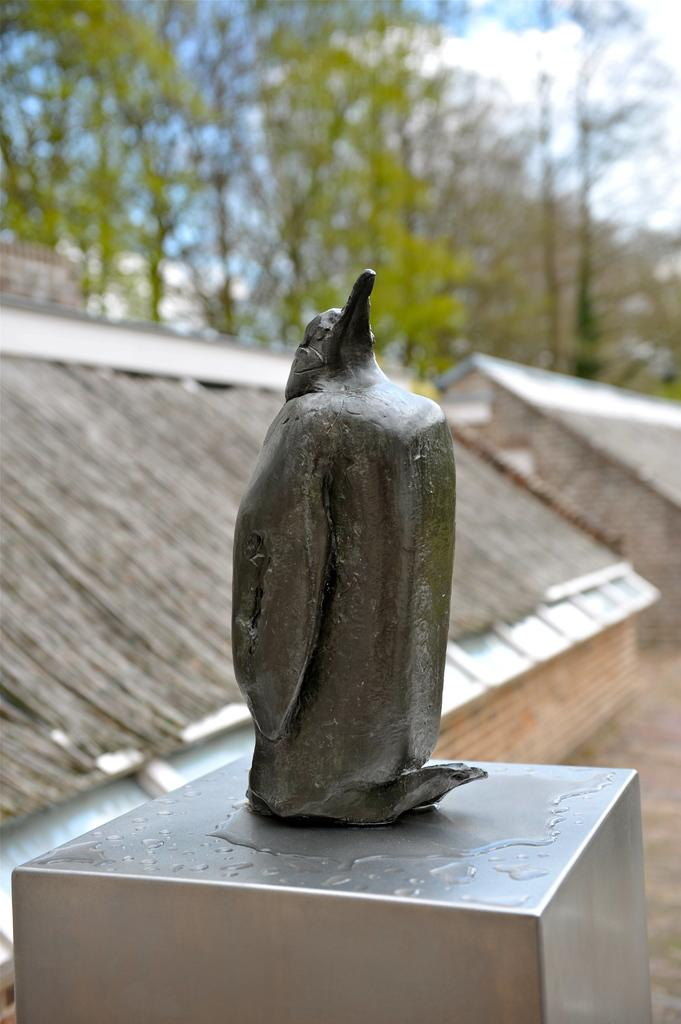What is the main subject in the image? There is a statue in the image. What is the statue resting on? The statue is on a metal object. What type of structures can be seen in the image? There are houses in the image. What type of vegetation is present in the image? There are trees in the image. What part of the natural environment is visible in the image? The sky is visible in the image. How many ants are crawling on the statue in the image? There are no ants present on the statue in the image. What historical event does the statue represent in the image? The facts provided do not mention any historical context or event related to the statue. 